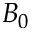<formula> <loc_0><loc_0><loc_500><loc_500>B _ { 0 }</formula> 